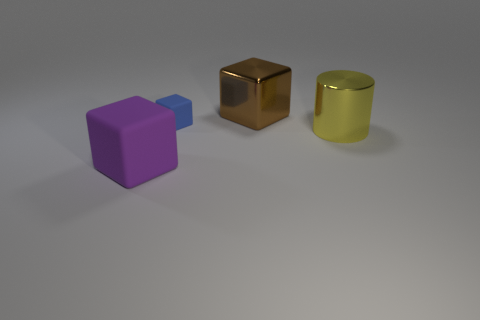What color is the metallic cylinder? The metallic cylinder in the image appears to be a shade of gold or brass, reflecting light with a muted yellowish hue, which suggests it might be made of a material similar to brass or anodized aluminum. 